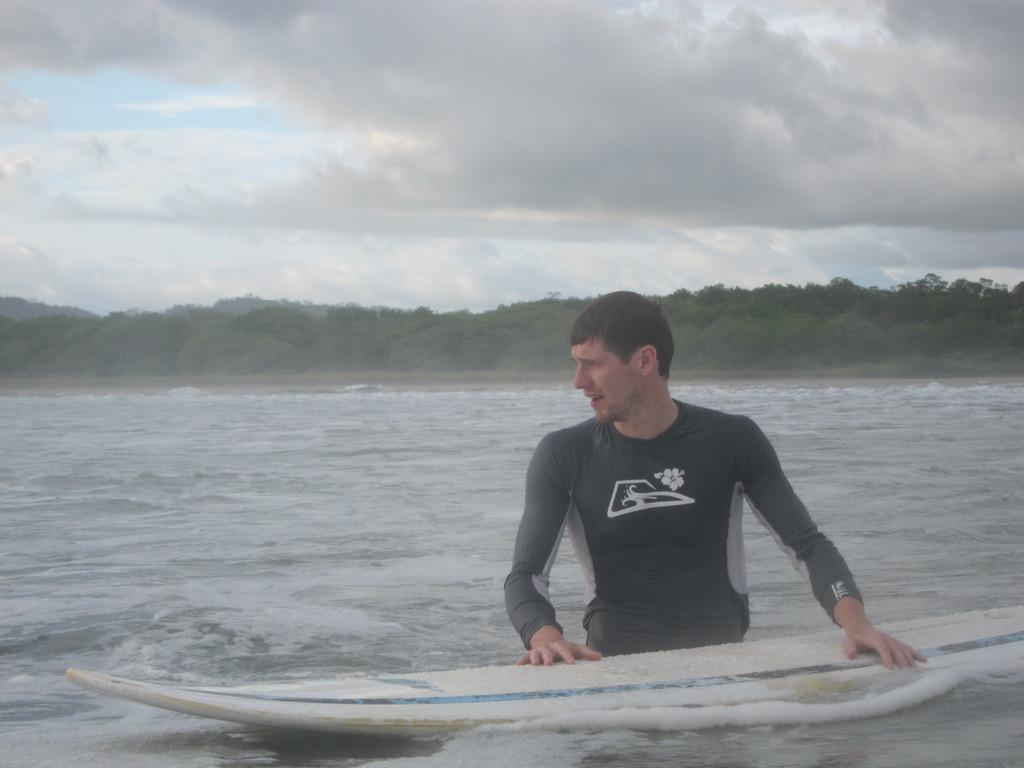Who is present in the image? There is a person in the image. What is the person holding in the image? The person is holding a surfing boat. Where does the scene take place? The scene takes place in the ocean. What type of vegetation can be seen in the image? There are trees visible in the image. What part of the natural environment is visible in the image? The sky is visible in the image. What type of attack system is being used by the person in the image? There is no attack system present in the image; the person is holding a surfing boat in the ocean. Can you tell me where the faucet is located in the image? There is no faucet present in the image; it takes place in the ocean with a person holding a surfing boat. 